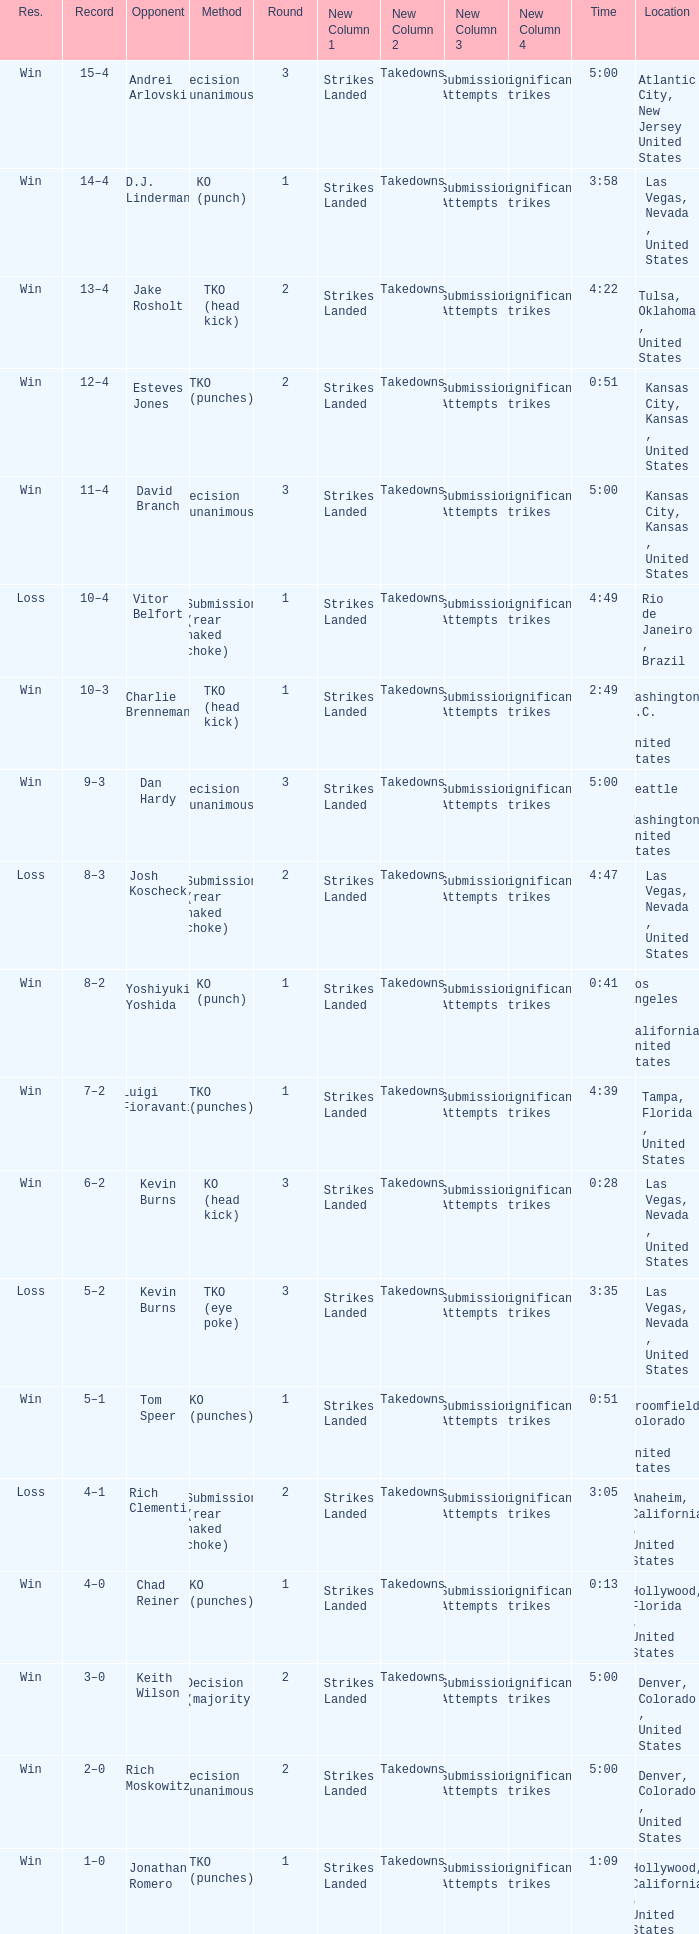Which record has a time of 0:13? 4–0. 